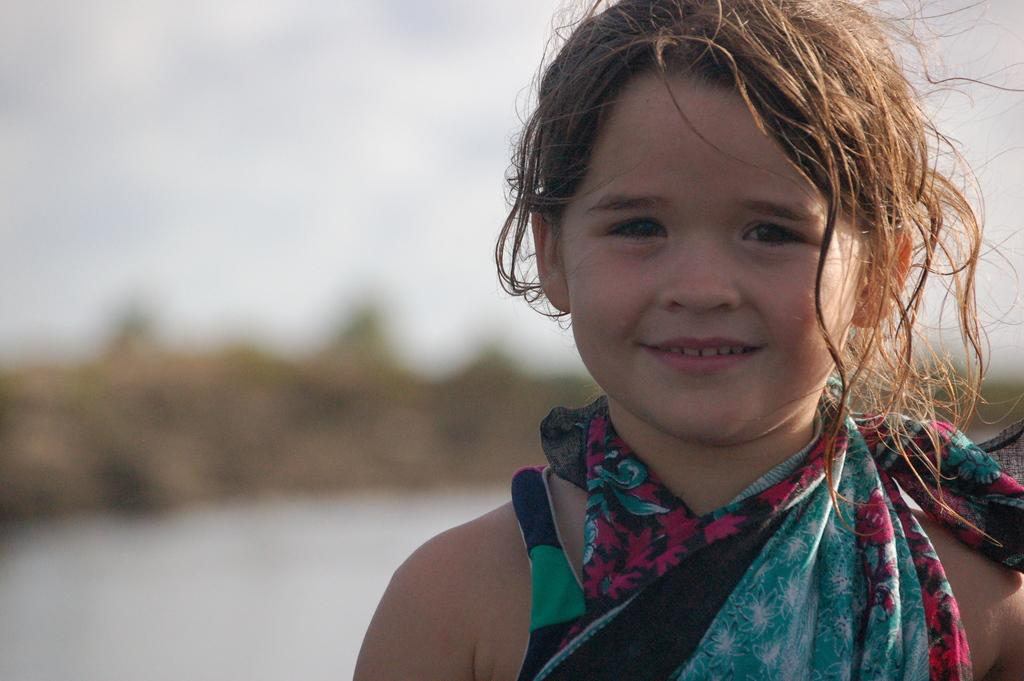What is the main subject on the right side of the image? There is a girl on the right side of the image. What is the girl's facial expression in the image? The girl is smiling in the image. How would you describe the background of the image? The background of the image is blurry. What type of attraction is present in the image? There is no attraction present in the image. 